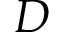Convert formula to latex. <formula><loc_0><loc_0><loc_500><loc_500>D</formula> 